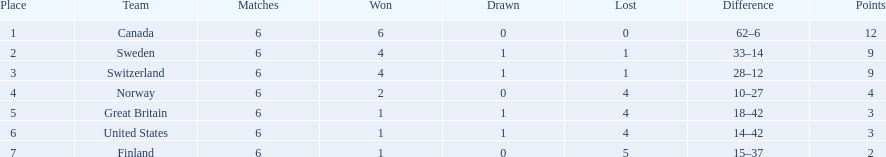Which are the two countries? Switzerland, Great Britain. What were the point totals for each of these countries? 9, 3. Of these point totals, which is better? 9. Which country earned this point total? Switzerland. 